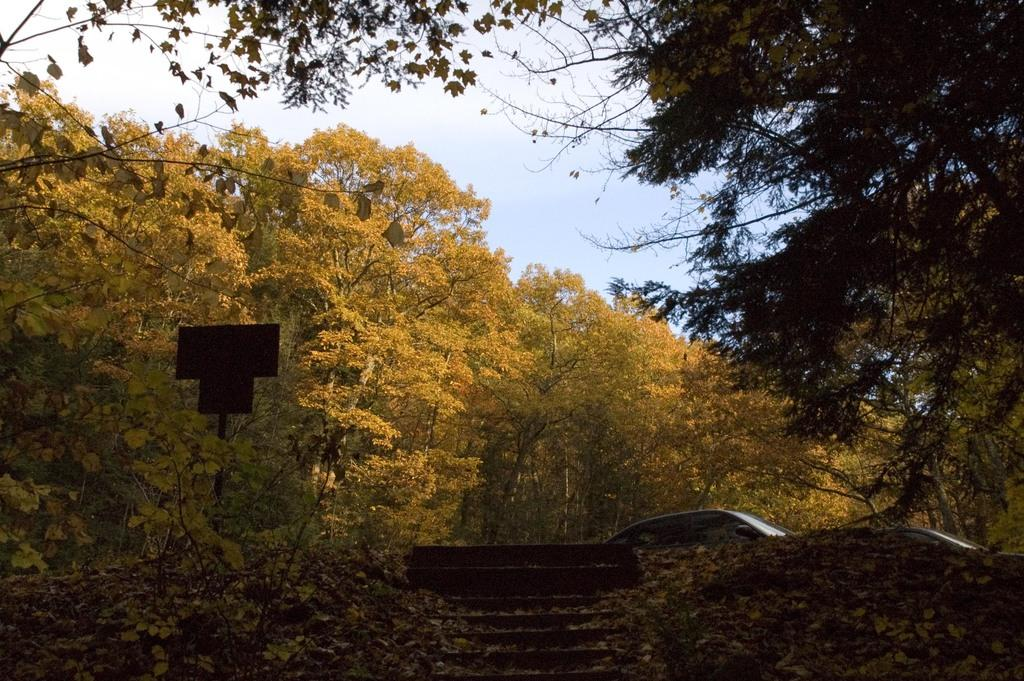What type of vegetation can be seen in the image? There are trees in the image. What is the color of the trees? The trees are green. What is attached to a pole on the left side of the image? There is a board attached to a pole on the left side of the image. What is visible at the top of the image? The sky is visible at the top of the image. What is the color of the sky? The color of the sky is white. Where is the quiver of arrows located in the image? There is no quiver of arrows present in the image. What type of nut can be seen growing on the trees in the image? There is no nut visible on the trees in the image. 